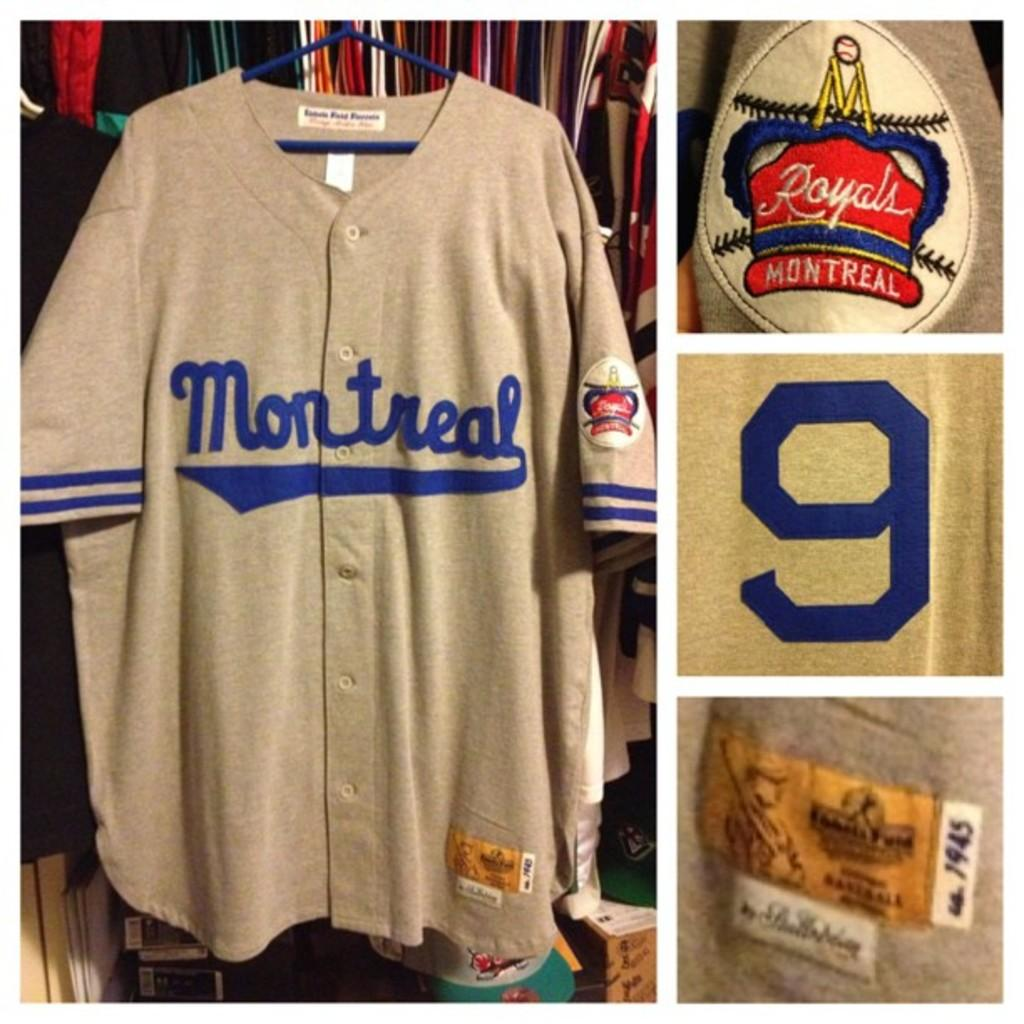<image>
Summarize the visual content of the image. An authentic Baseball jersey says Montreal on it and has the number 9 on its sleeve. 